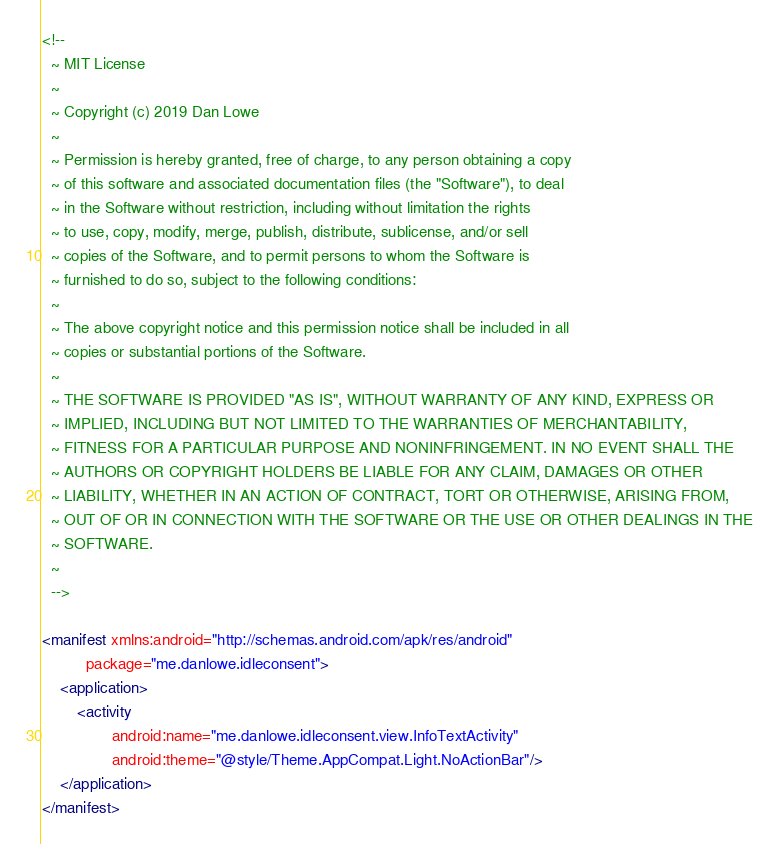Convert code to text. <code><loc_0><loc_0><loc_500><loc_500><_XML_><!--
  ~ MIT License
  ~
  ~ Copyright (c) 2019 Dan Lowe
  ~
  ~ Permission is hereby granted, free of charge, to any person obtaining a copy
  ~ of this software and associated documentation files (the "Software"), to deal
  ~ in the Software without restriction, including without limitation the rights
  ~ to use, copy, modify, merge, publish, distribute, sublicense, and/or sell
  ~ copies of the Software, and to permit persons to whom the Software is
  ~ furnished to do so, subject to the following conditions:
  ~
  ~ The above copyright notice and this permission notice shall be included in all
  ~ copies or substantial portions of the Software.
  ~
  ~ THE SOFTWARE IS PROVIDED "AS IS", WITHOUT WARRANTY OF ANY KIND, EXPRESS OR
  ~ IMPLIED, INCLUDING BUT NOT LIMITED TO THE WARRANTIES OF MERCHANTABILITY,
  ~ FITNESS FOR A PARTICULAR PURPOSE AND NONINFRINGEMENT. IN NO EVENT SHALL THE
  ~ AUTHORS OR COPYRIGHT HOLDERS BE LIABLE FOR ANY CLAIM, DAMAGES OR OTHER
  ~ LIABILITY, WHETHER IN AN ACTION OF CONTRACT, TORT OR OTHERWISE, ARISING FROM,
  ~ OUT OF OR IN CONNECTION WITH THE SOFTWARE OR THE USE OR OTHER DEALINGS IN THE
  ~ SOFTWARE.
  ~
  -->

<manifest xmlns:android="http://schemas.android.com/apk/res/android"
          package="me.danlowe.idleconsent">
    <application>
        <activity
                android:name="me.danlowe.idleconsent.view.InfoTextActivity"
                android:theme="@style/Theme.AppCompat.Light.NoActionBar"/>
    </application>
</manifest>
</code> 